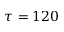<formula> <loc_0><loc_0><loc_500><loc_500>\tau = 1 2 0</formula> 